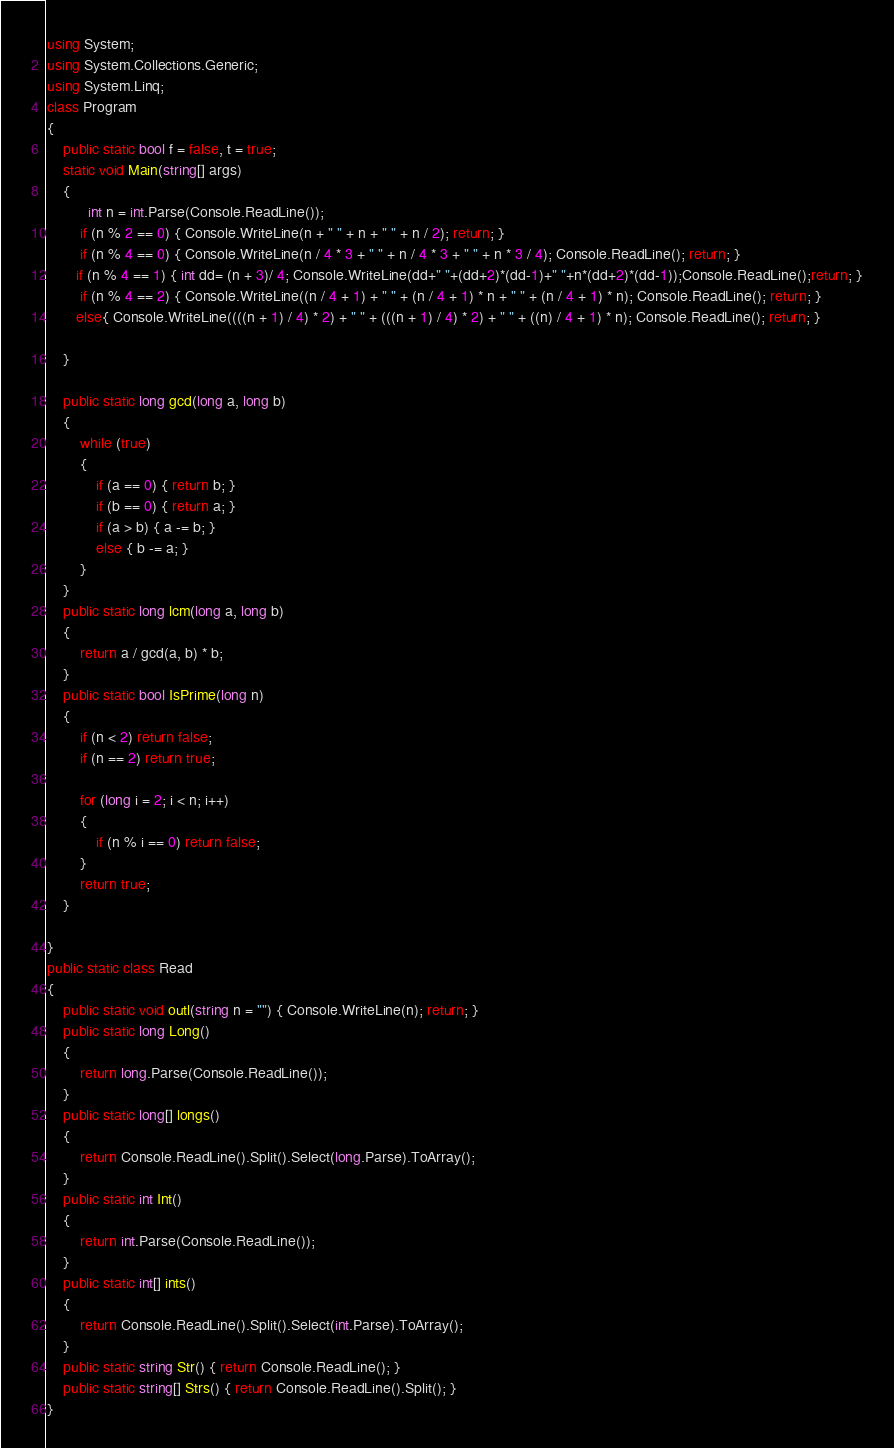Convert code to text. <code><loc_0><loc_0><loc_500><loc_500><_C#_>using System;
using System.Collections.Generic;
using System.Linq;
class Program
{
    public static bool f = false, t = true;
    static void Main(string[] args)
    {
          int n = int.Parse(Console.ReadLine());
        if (n % 2 == 0) { Console.WriteLine(n + " " + n + " " + n / 2); return; }
        if (n % 4 == 0) { Console.WriteLine(n / 4 * 3 + " " + n / 4 * 3 + " " + n * 3 / 4); Console.ReadLine(); return; }
       if (n % 4 == 1) { int dd= (n + 3)/ 4; Console.WriteLine(dd+" "+(dd+2)*(dd-1)+" "+n*(dd+2)*(dd-1));Console.ReadLine();return; }
        if (n % 4 == 2) { Console.WriteLine((n / 4 + 1) + " " + (n / 4 + 1) * n + " " + (n / 4 + 1) * n); Console.ReadLine(); return; }
       else{ Console.WriteLine((((n + 1) / 4) * 2) + " " + (((n + 1) / 4) * 2) + " " + ((n) / 4 + 1) * n); Console.ReadLine(); return; }
    
    }

    public static long gcd(long a, long b)
    {
        while (true)
        {
            if (a == 0) { return b; }
            if (b == 0) { return a; }
            if (a > b) { a -= b; }
            else { b -= a; }
        }
    }
    public static long lcm(long a, long b)
    {
        return a / gcd(a, b) * b;
    }
    public static bool IsPrime(long n)
    {
        if (n < 2) return false;
        if (n == 2) return true;

        for (long i = 2; i < n; i++)
        {
            if (n % i == 0) return false;
        }
        return true;
    }

}
public static class Read
{
    public static void outl(string n = "") { Console.WriteLine(n); return; }
    public static long Long()
    {
        return long.Parse(Console.ReadLine());
    }
    public static long[] longs()
    {
        return Console.ReadLine().Split().Select(long.Parse).ToArray();
    }
    public static int Int()
    {
        return int.Parse(Console.ReadLine());
    }
    public static int[] ints()
    {
        return Console.ReadLine().Split().Select(int.Parse).ToArray();
    }
    public static string Str() { return Console.ReadLine(); }
    public static string[] Strs() { return Console.ReadLine().Split(); }
}</code> 